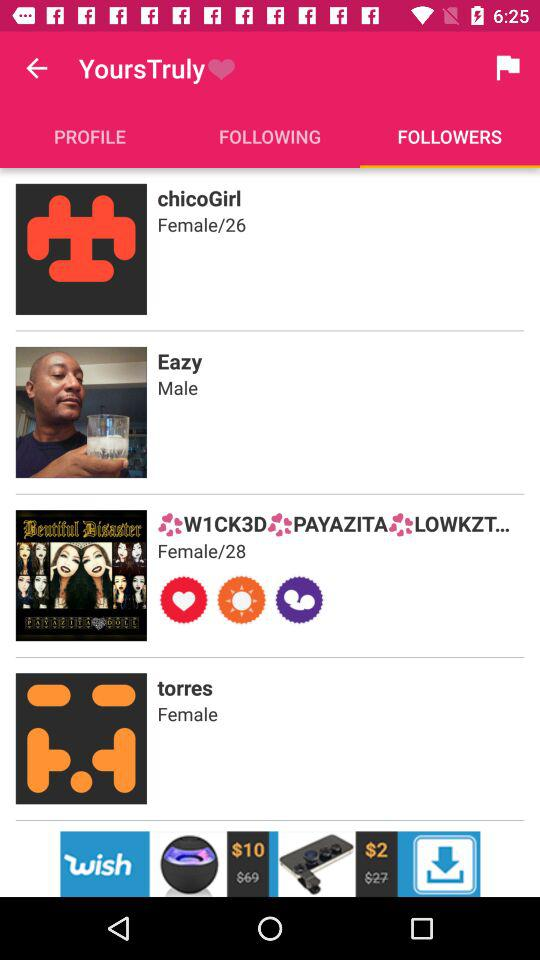What is the gender of Eazy? The gender is male. 